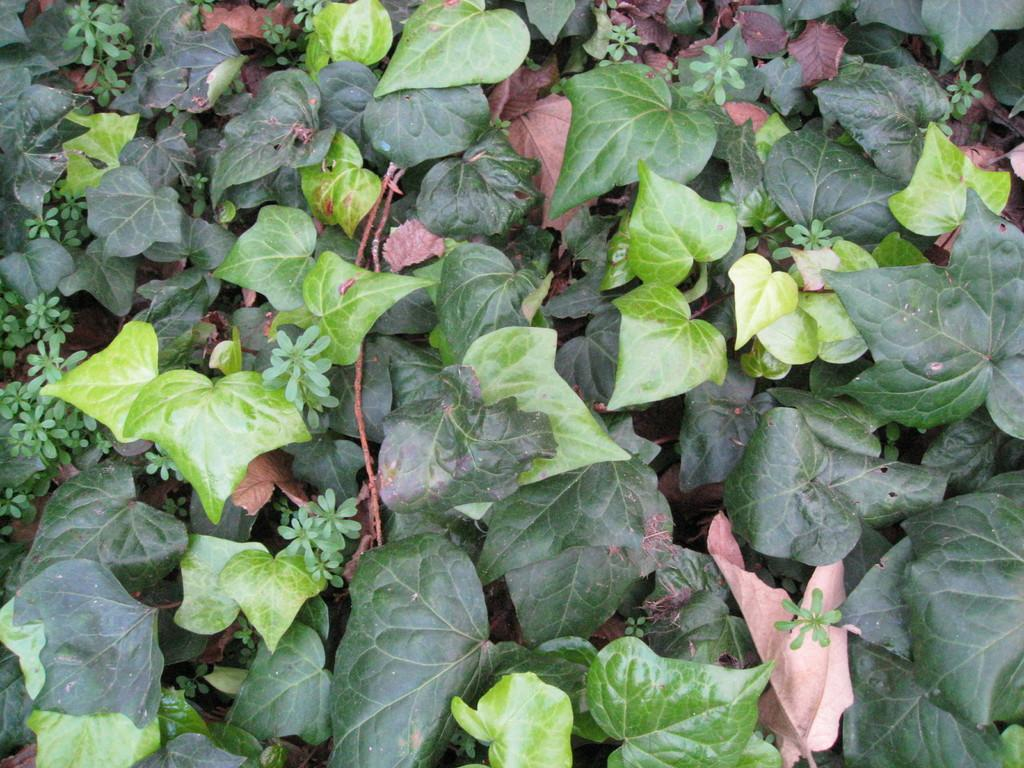What type of vegetation can be seen in the image? There are leaves and plants in the image. Can you describe the plants in the image? The plants in the image have leaves. What type of quilt is being used to cover the plants in the image? There is no quilt present in the image; it only features leaves and plants. What team is responsible for maintaining the plants in the image? There is no team mentioned or depicted in the image, as it only shows plants and leaves. 